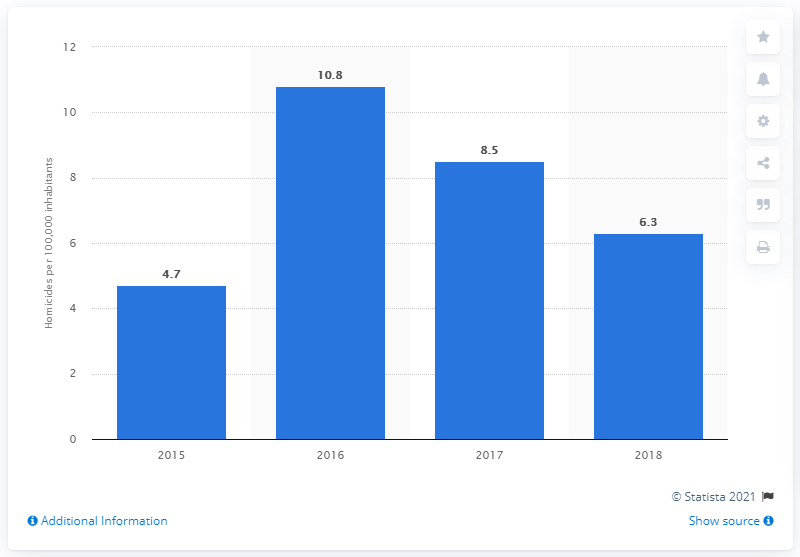Highlight a few significant elements in this photo. The homicide rate in Bolivia in 2015 was 8.5 per 100,000 people. The homicide rate in Bolivia in 2018 was 6.3 per 100,000 inhabitants. 